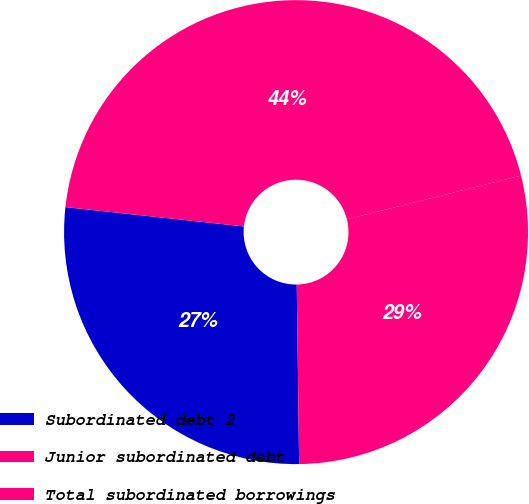<chart> <loc_0><loc_0><loc_500><loc_500><pie_chart><fcel>Subordinated debt 2<fcel>Junior subordinated debt<fcel>Total subordinated borrowings<nl><fcel>26.93%<fcel>44.36%<fcel>28.71%<nl></chart> 